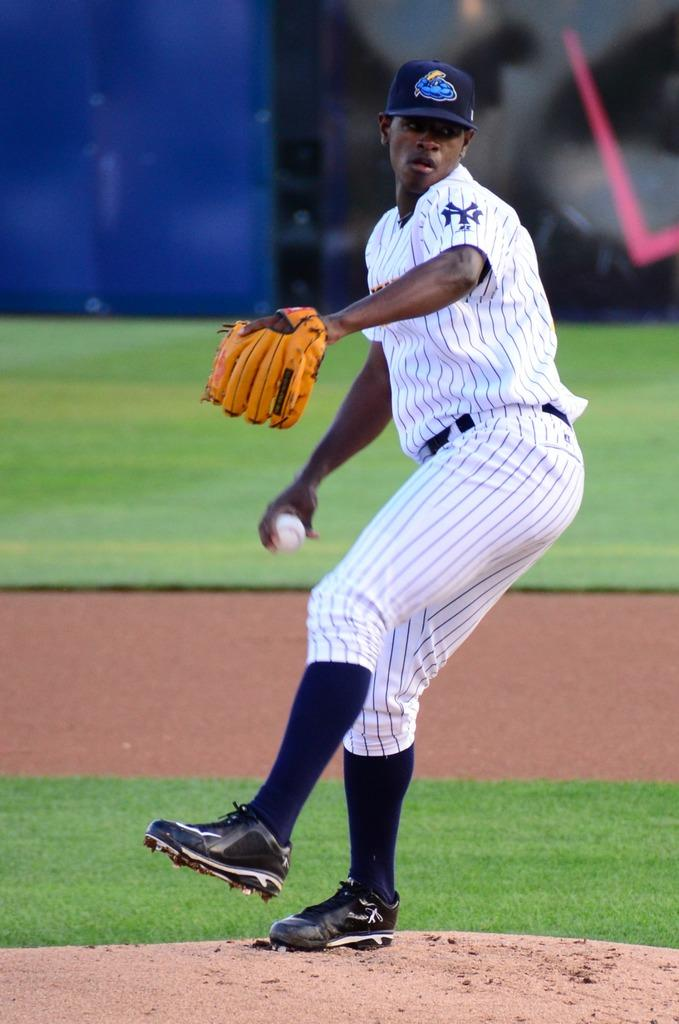<image>
Give a short and clear explanation of the subsequent image. A baseball player with NY on his sleeve is about to throw the ball. 